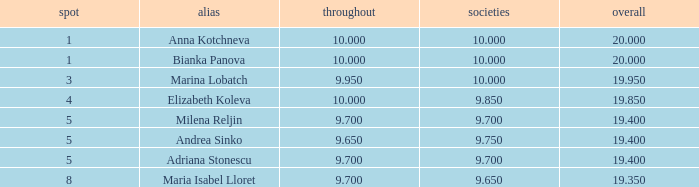What total has 10 as the clubs, with a place greater than 1? 19.95. 